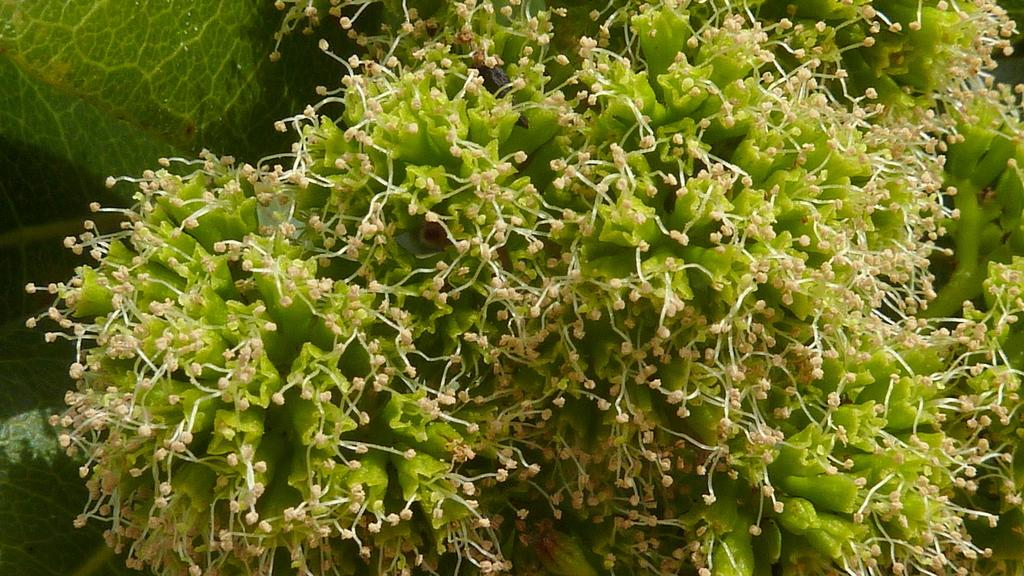What type of living organism is in the image? There is a plant in the image. What color are the leaves of the plant? The leaves of the plant are green. What additional features can be seen on the plant? The plant has flowers. What type of button can be seen on the boat in the image? There is no button or boat present in the image; it only features a plant with green leaves and flowers. 